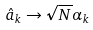Convert formula to latex. <formula><loc_0><loc_0><loc_500><loc_500>\hat { a } _ { k } \rightarrow \sqrt { N } \alpha _ { k }</formula> 